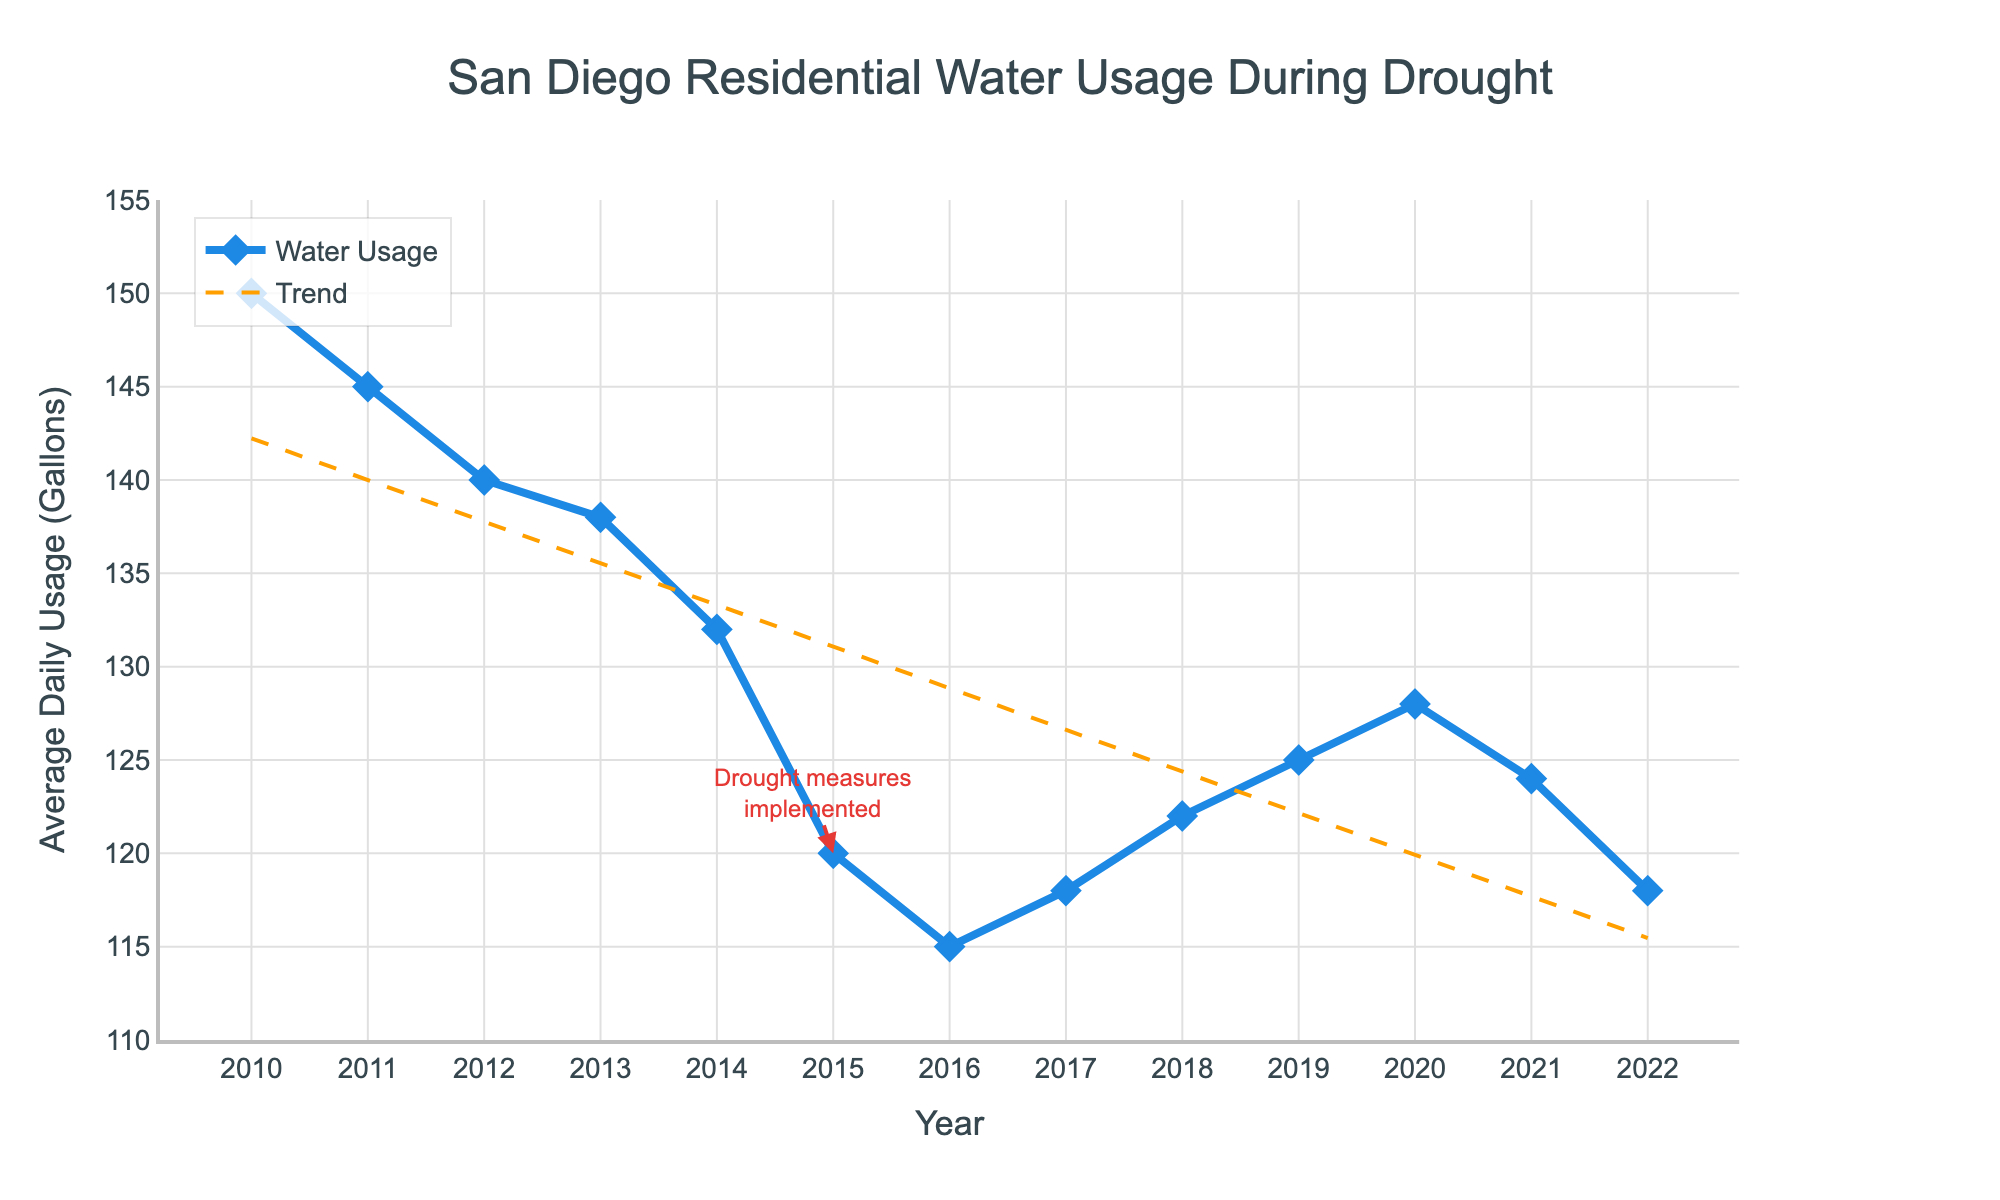what year shows the lowest average daily residential water usage? Look for the lowest point on the line chart. According to the figure, the lowest average water usage is in 2016 at 115 gallons per day.
Answer: 2016 How does the water usage in 2022 compare to that in 2010? Identify the trends in the graph for the two years. Water usage in 2022 is 118 gallons per day, whereas in 2010 it was 150 gallons per day. The usage has decreased by 32 gallons per day over this period.
Answer: Decreased by 32 gallons What is the trend of average daily water usage over the years according to the added trend line? Observe the overall direction of the dashed trend line. The trend line generally shows a decrease from 2010 to 2022, indicative of reducing water usage.
Answer: Decreasing In which year were drought measures implemented, and what was the water usage that year? Find the annotation on the chart indicating when drought measures were implemented. This occurred in 2015 when the average water usage was 120 gallons per day.
Answer: 2015, 120 gallons Calculate the average daily water usage from 2010 to 2015. Add the water usage values for each year from 2010 to 2015 and divide by the number of years (6 years). (150 + 145 + 140 + 138 + 132 + 120) = 825. The average is 825 / 6 = 137.5 gallons per day.
Answer: 137.5 gallons Which year had a higher average daily residential water usage, 2017 or 2019, and by how much? Compare the values for 2017 and 2019. In 2017, the usage is 118 gallons per day, while in 2019 it is 125 gallons per day. Difference: 125 - 118 = 7 gallons per day.
Answer: 2019, by 7 gallons What is the approximate range of average daily water usage shown in the figure? Identify the highest and lowest points on the line chart. The highest is 150 gallons (2010); the lowest is 115 gallons (2016). Range: 150 - 115 = 35 gallons per day.
Answer: 35 gallons Between which consecutive years did the largest decrease in water usage occur? Calculate the differences between consecutive years' water usage and identify the largest one. The largest decrease is between 2014 (132 gallons) and 2015 (120 gallons), a difference of 12 gallons.
Answer: 2014 to 2015, 12 gallons What visual attributes distinguish the trend line from the main line in the chart? Describe the visual differences between the two lines in the figure. The trend line is orange and dashed, while the main line is blue, solid, thicker, and includes markers.
Answer: Orange, dashed vs. blue, solid, thicker, with markers Compare the water usage in 2018 to the water usage in 2020. Check the water usage values for both years. In 2018, it is 122 gallons per day, and in 2020, it is 128 gallons per day.
Answer: 2020 is higher by 6 gallons 